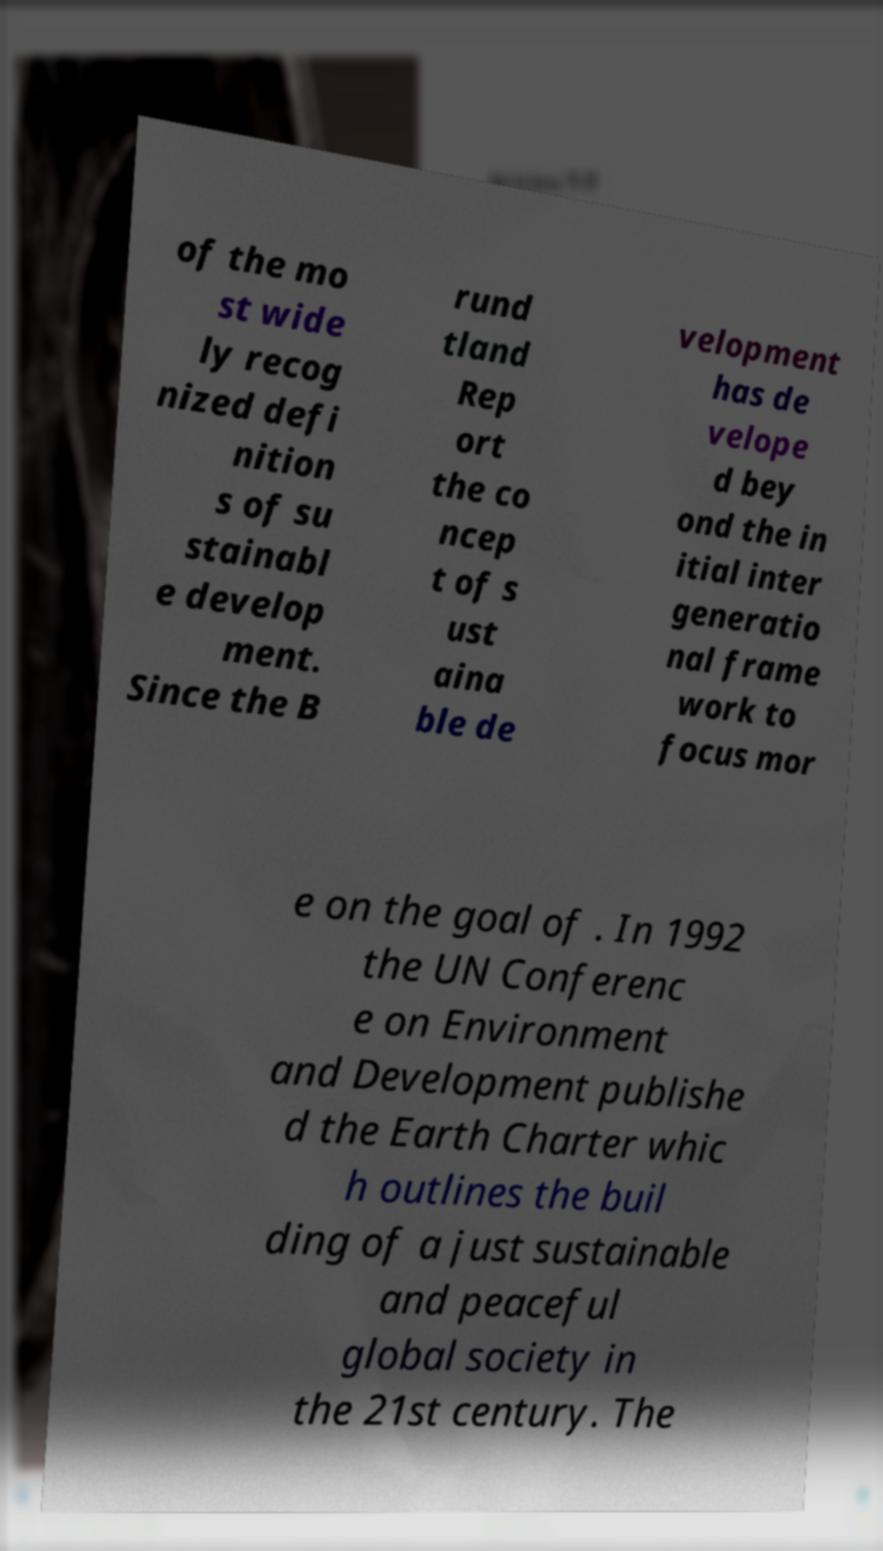For documentation purposes, I need the text within this image transcribed. Could you provide that? of the mo st wide ly recog nized defi nition s of su stainabl e develop ment. Since the B rund tland Rep ort the co ncep t of s ust aina ble de velopment has de velope d bey ond the in itial inter generatio nal frame work to focus mor e on the goal of . In 1992 the UN Conferenc e on Environment and Development publishe d the Earth Charter whic h outlines the buil ding of a just sustainable and peaceful global society in the 21st century. The 